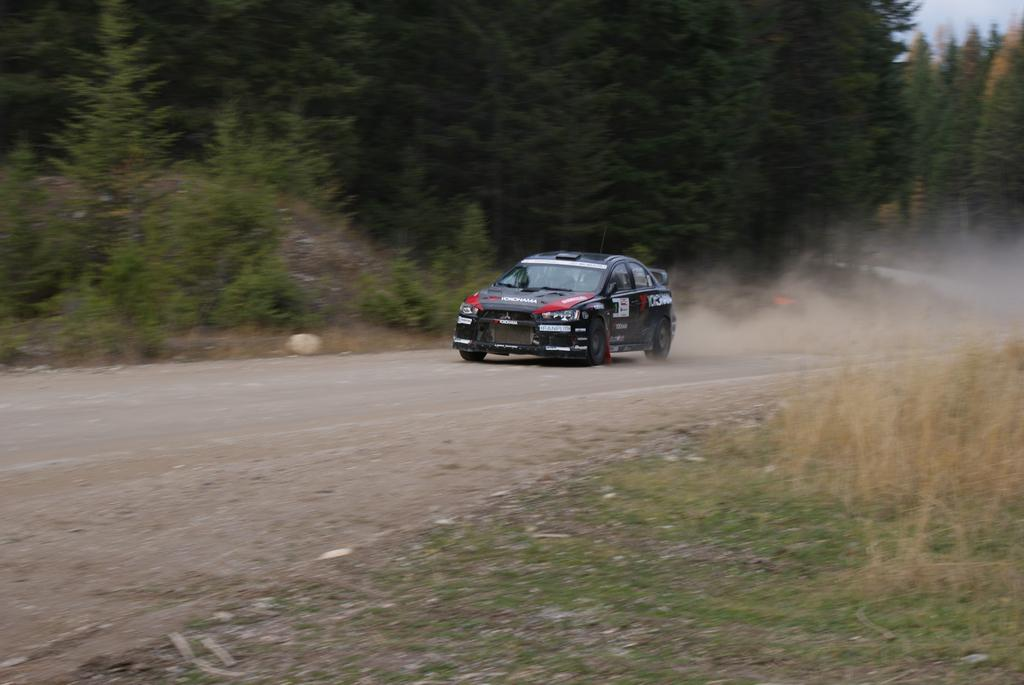What is the main subject of the image? There is a vehicle on the road in the image. What can be seen on the left side of the image? There are trees on the left side of the image. What part of the natural environment is visible in the image? The sky is visible in the image. What type of calculator can be seen on the vehicle in the image? There is no calculator present on the vehicle in the image. What is your opinion on the color of the vehicle in the image? The provided facts do not include any information about the color of the vehicle, so it is not possible to provide an opinion on it. 